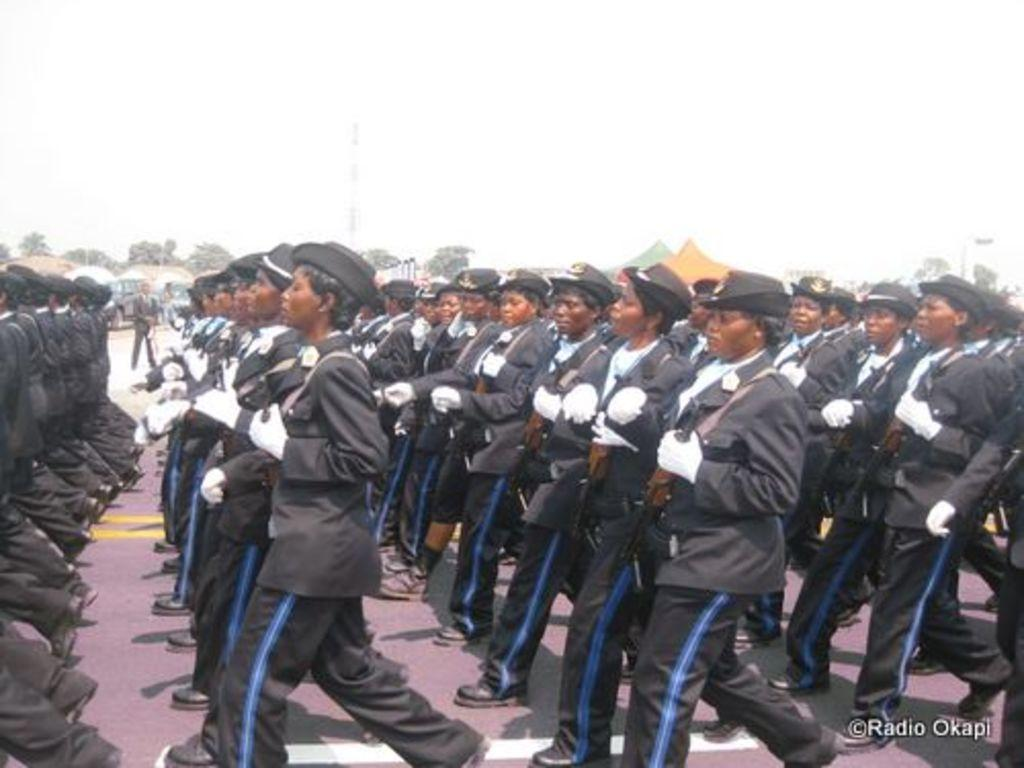How many people are in the image? There are people in the image, but the exact number is not specified. What are the people doing in the image? The people are walking in the image. What are the people holding in the image? The people are holding weapons in the image. What type of temporary shelter can be seen in the image? There are tents in the image. What type of vegetation is visible in the image? There are trees in the image. What is visible at the top of the image? The sky is visible at the top of the image. What type of boat is being used by the plant in the image? There is no boat or plant present in the image. Who is the manager of the group in the image? There is no mention of a manager or group in the image. 